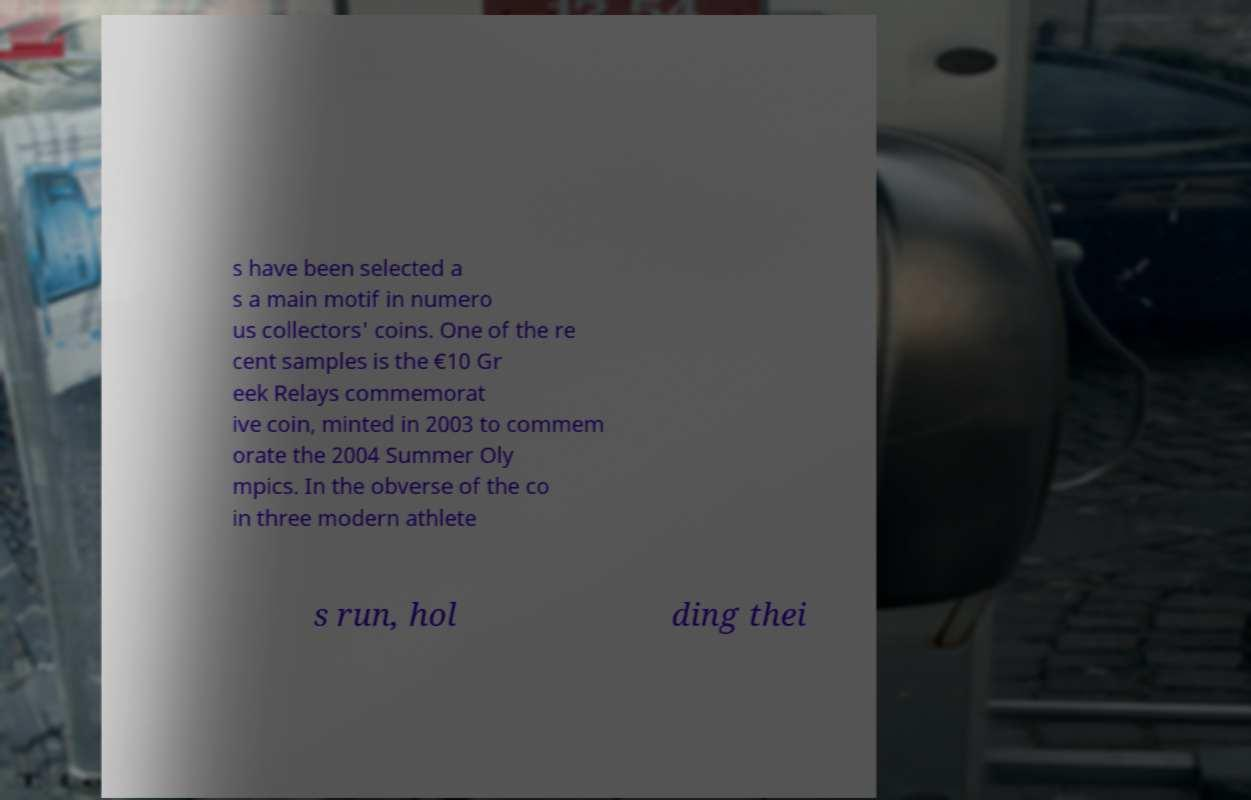Please identify and transcribe the text found in this image. s have been selected a s a main motif in numero us collectors' coins. One of the re cent samples is the €10 Gr eek Relays commemorat ive coin, minted in 2003 to commem orate the 2004 Summer Oly mpics. In the obverse of the co in three modern athlete s run, hol ding thei 